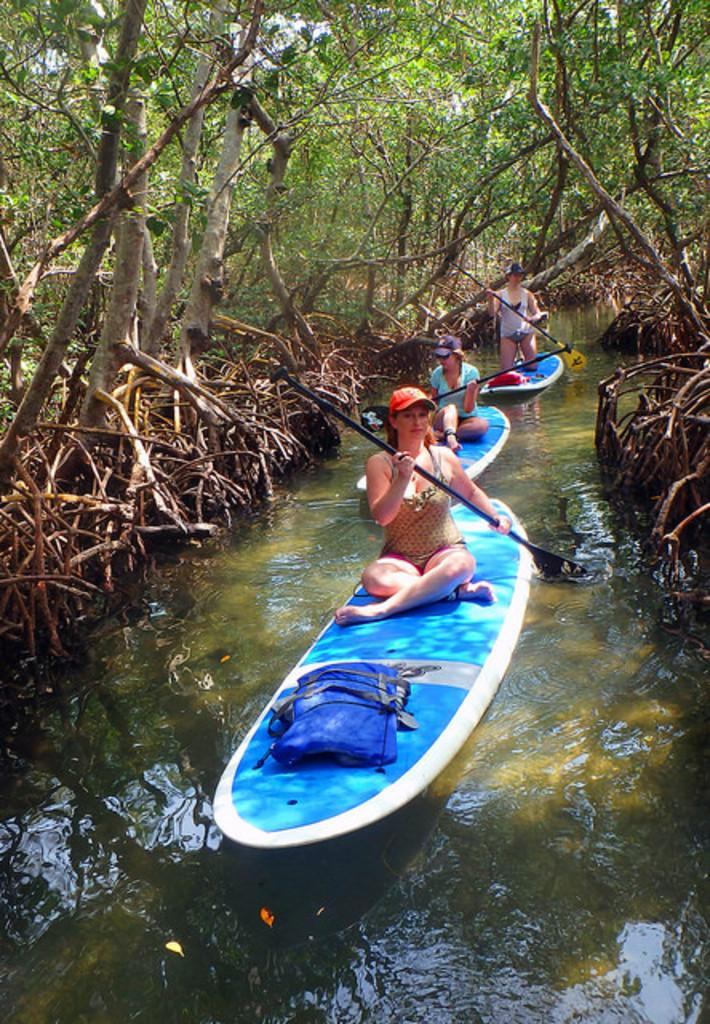What are the people in the image doing? The people in the image are rowing boats. Where are the boats located? The boats are on the water. What can be seen on the left side of the image? There are trees on the left side of the image. Can you see a volcano erupting in the image? No, there is no volcano present in the image. What type of shirt is the person in the boat wearing? There is no person's shirt visible in the image, as the focus is on the people rowing the boats and the boats themselves. 